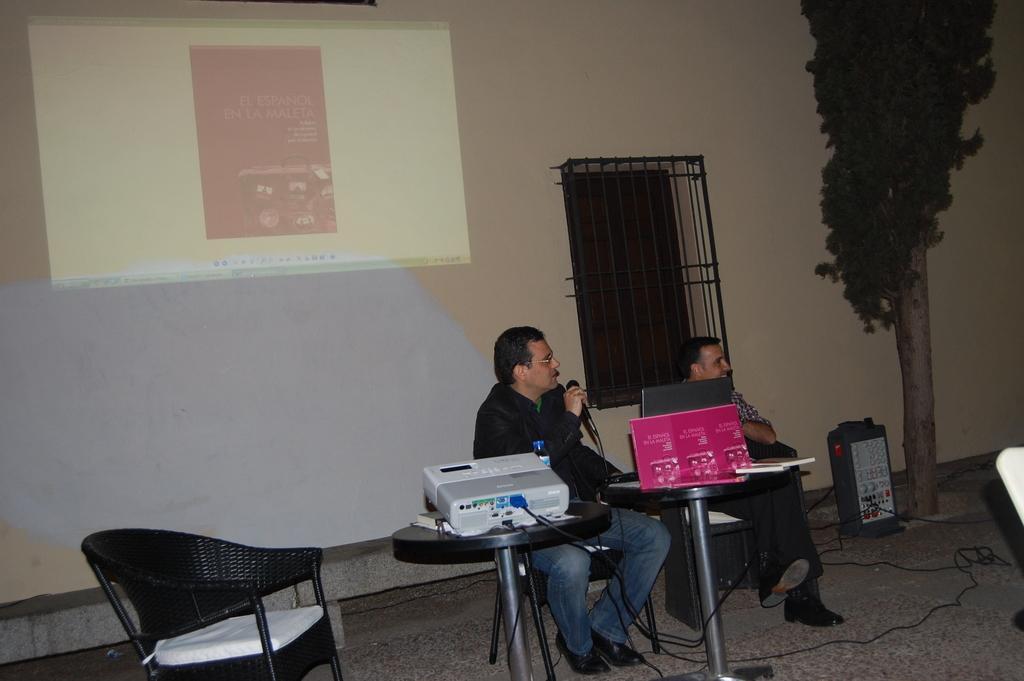How would you summarize this image in a sentence or two? In this image I can see two men were one man is holding a mic in his hand. I can also see few chairs and In background I can see a tree and a projector screen on this wall. 